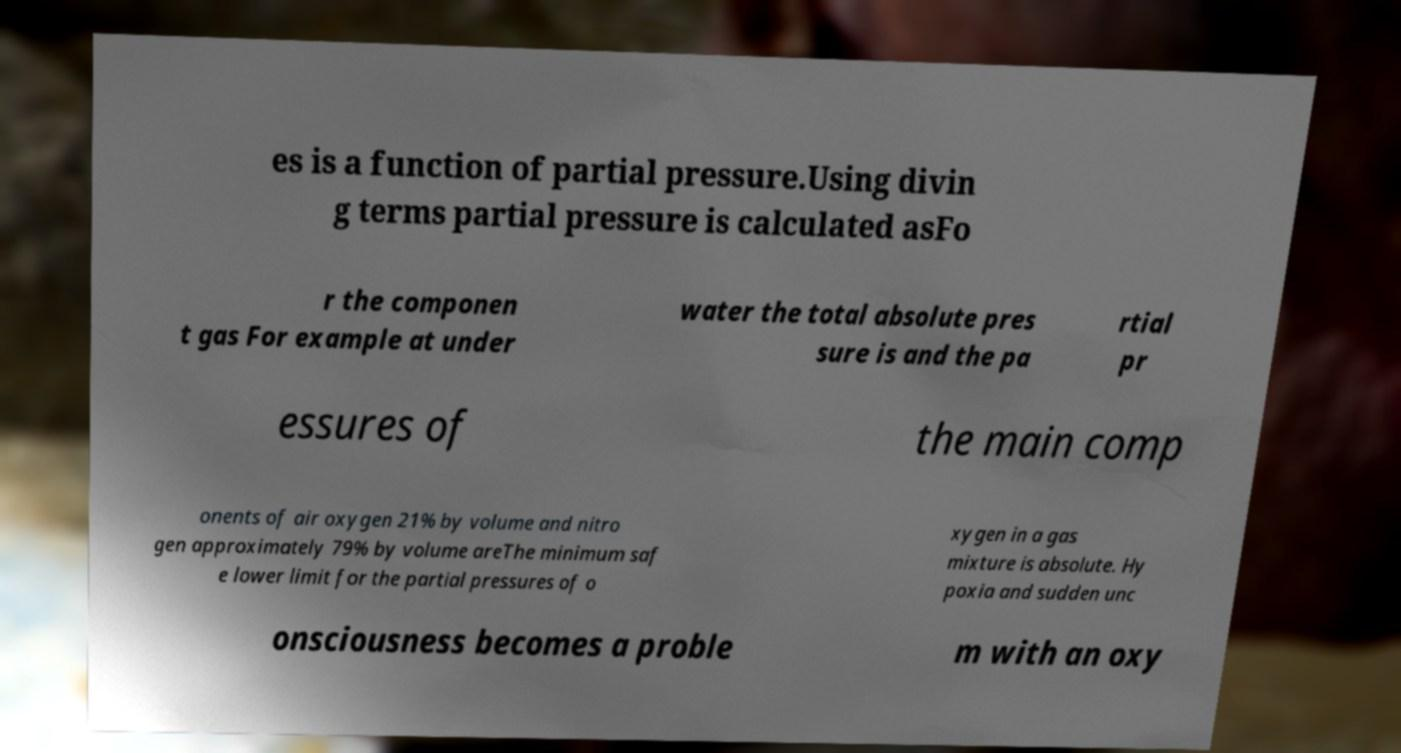There's text embedded in this image that I need extracted. Can you transcribe it verbatim? es is a function of partial pressure.Using divin g terms partial pressure is calculated asFo r the componen t gas For example at under water the total absolute pres sure is and the pa rtial pr essures of the main comp onents of air oxygen 21% by volume and nitro gen approximately 79% by volume areThe minimum saf e lower limit for the partial pressures of o xygen in a gas mixture is absolute. Hy poxia and sudden unc onsciousness becomes a proble m with an oxy 